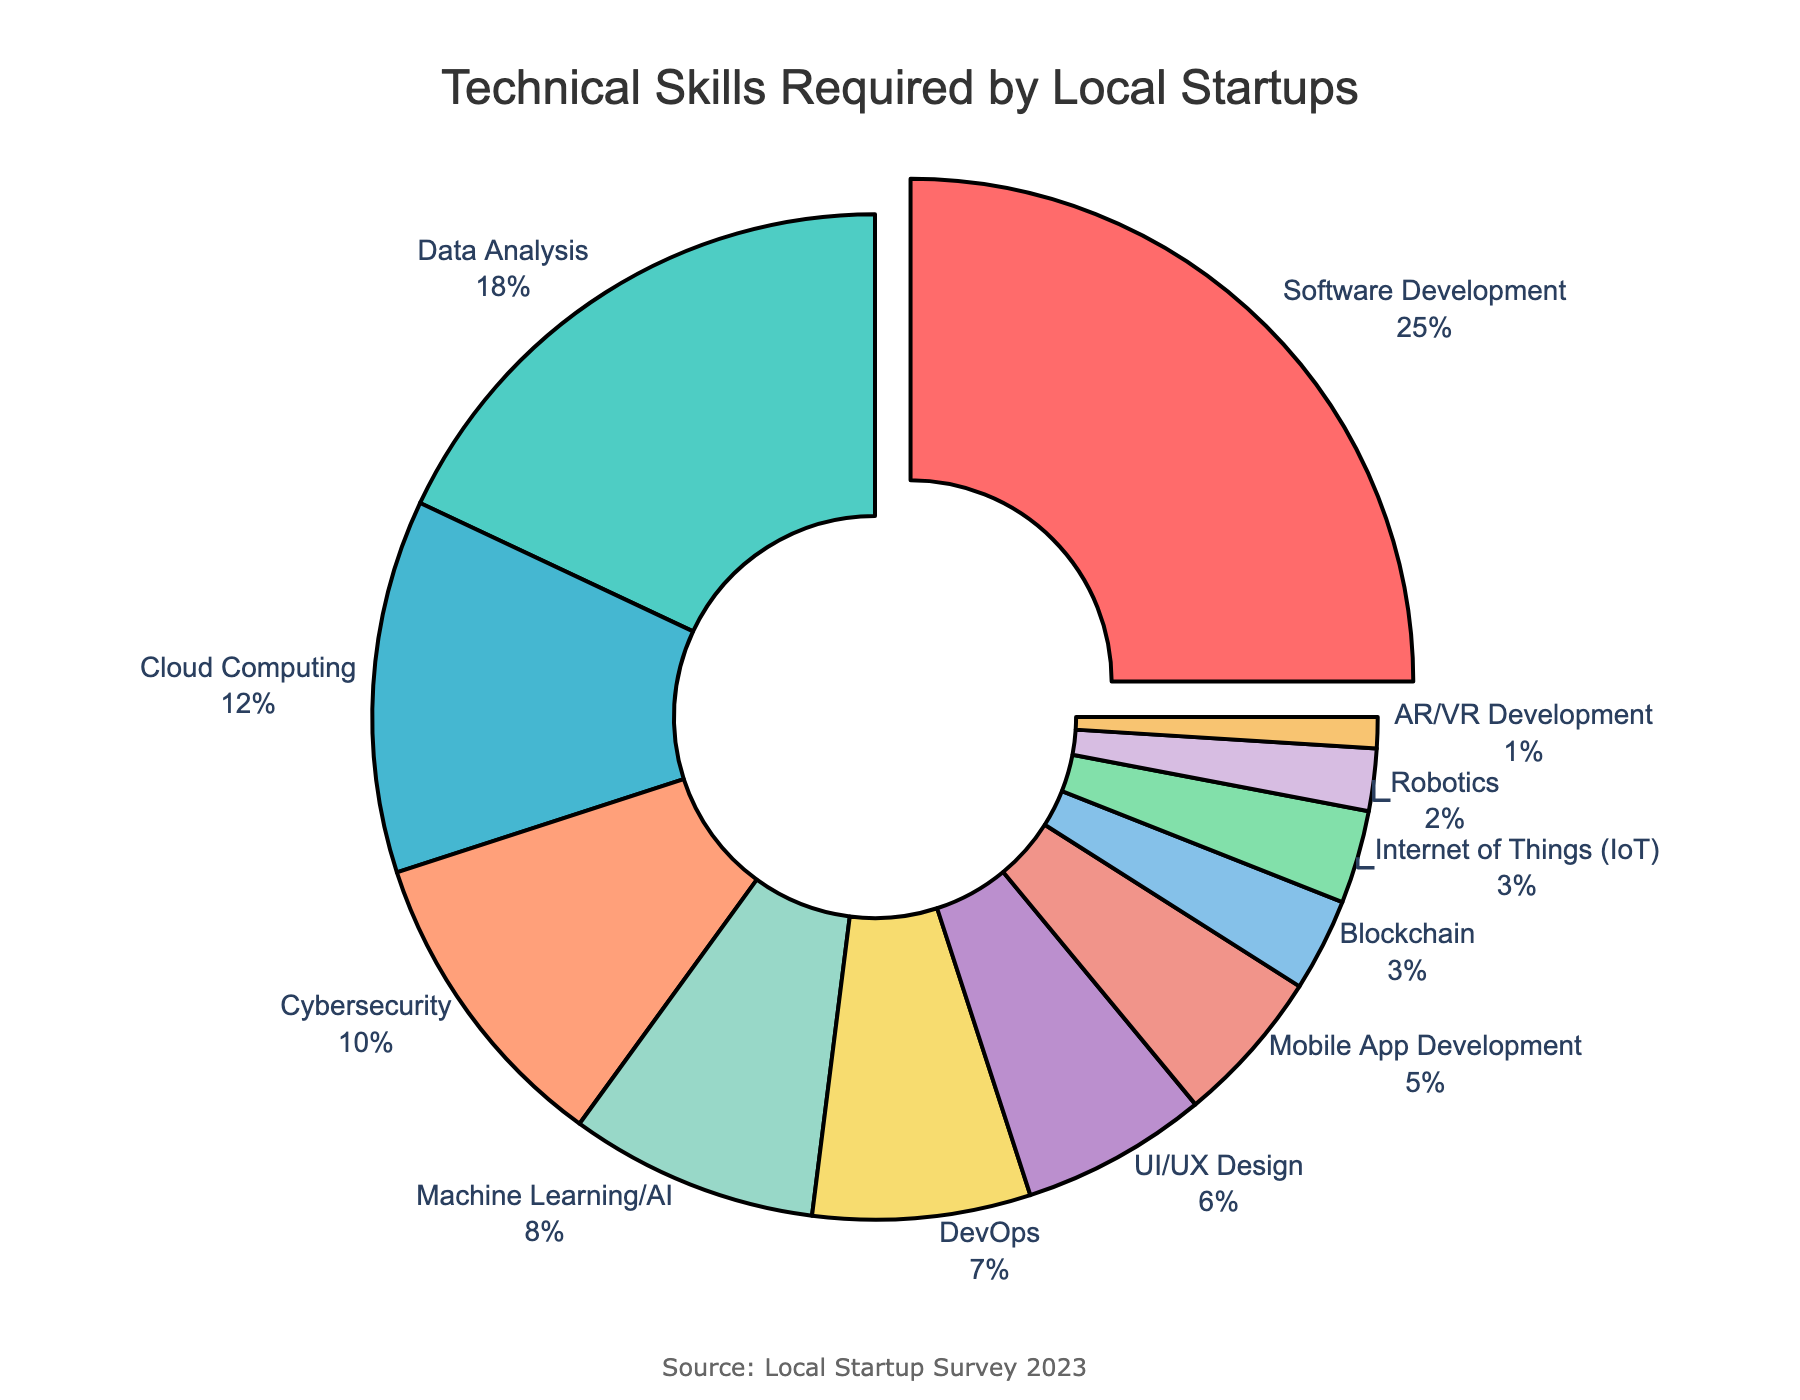Which technical skill is required the most by local startups? The figure shows a pie chart where each segment represents a different skill. The segment for Software Development is the largest, indicating it has the highest percentage.
Answer: Software Development How much more is the percentage of Software Development compared to Data Analysis? Software Development has a segment representing 25%, and Data Analysis has a segment representing 18%. The difference is 25% - 18%.
Answer: 7% What is the combined percentage of skills with under 10% each? Summing the percentages for skills under 10%: Cybersecurity (10%) + Machine Learning/AI (8%) + DevOps (7%) + UI/UX Design (6%) + Mobile App Development (5%) + Blockchain (3%) + IoT (3%) + Robotics (2%) + AR/VR Development (1%) = 45%.
Answer: 45% Which skill has a higher percentage, Cybersecurity or Cloud Computing? By comparing the segments, Cybersecurity has 10%, and Cloud Computing has 12%. Thus, Cloud Computing has a higher percentage.
Answer: Cloud Computing What is the percentage of DevOps compared to the total percentage for Machine Learning/AI and Cybersecurity combined? DevOps has 7%, while Machine Learning/AI has 8% and Cybersecurity has 10%. The combined total for Machine Learning/AI and Cybersecurity is 18%. Comparing DevOps to this combined total, 7% is less than 18%.
Answer: Less What two skills combine to make up exactly 15%? From the chart, Mobile App Development is 5% and UI/UX Design is 6%. Adding another skill with 3%, such as Blockchain or IoT, we get 5% + 6% + 3% = 14%. None of the pairs combine to exactly 15%.
Answer: None What color represents the skill with the smallest percentage? The AR/VR Development skill has the smallest percentage (1%). The corresponding color for this segment is shown as a lighter color in the pie chart, typically the last one in the color sequence used.
Answer: Light orange (as per the example colors) Which skill has nearly the same percentage as Machine Learning/AI? Machine Learning/AI is at 8%. DevOps, which has a 7% segment, is the closest in percentage to Machine Learning/AI.
Answer: DevOps Between Data Analysis and UI/UX Design, which one has a bigger share? Data Analysis has 18% while UI/UX Design has 6%. Comparing these, Data Analysis has a bigger share.
Answer: Data Analysis 